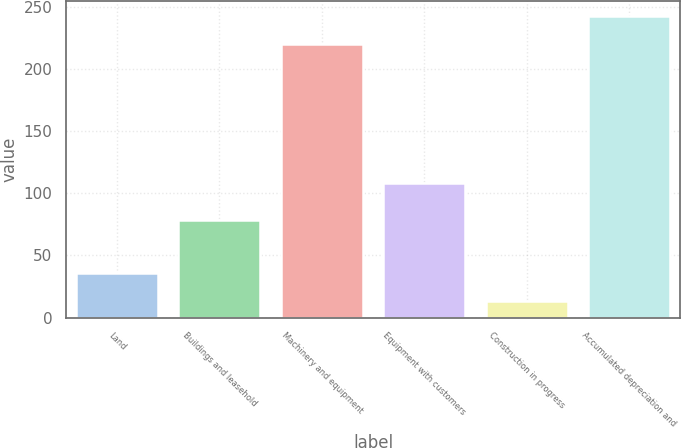Convert chart to OTSL. <chart><loc_0><loc_0><loc_500><loc_500><bar_chart><fcel>Land<fcel>Buildings and leasehold<fcel>Machinery and equipment<fcel>Equipment with customers<fcel>Construction in progress<fcel>Accumulated depreciation and<nl><fcel>35.81<fcel>78.7<fcel>219.7<fcel>108.5<fcel>13.5<fcel>242.01<nl></chart> 